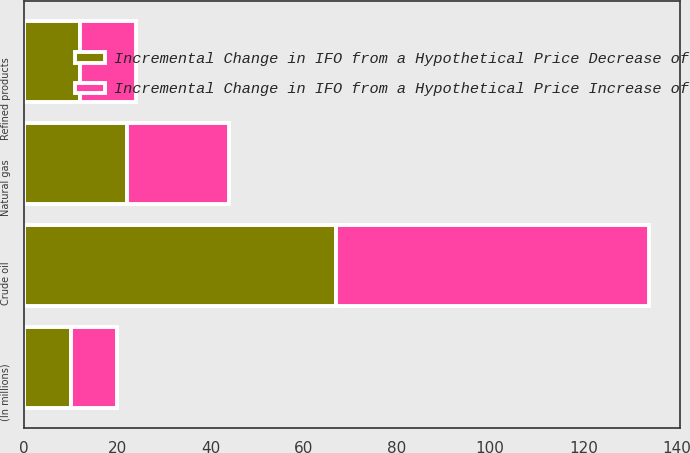Convert chart. <chart><loc_0><loc_0><loc_500><loc_500><stacked_bar_chart><ecel><fcel>(In millions)<fcel>Crude oil<fcel>Natural gas<fcel>Refined products<nl><fcel>Incremental Change in IFO from a Hypothetical Price Decrease of<fcel>10<fcel>67<fcel>22<fcel>12<nl><fcel>Incremental Change in IFO from a Hypothetical Price Increase of<fcel>10<fcel>67<fcel>22<fcel>12<nl></chart> 